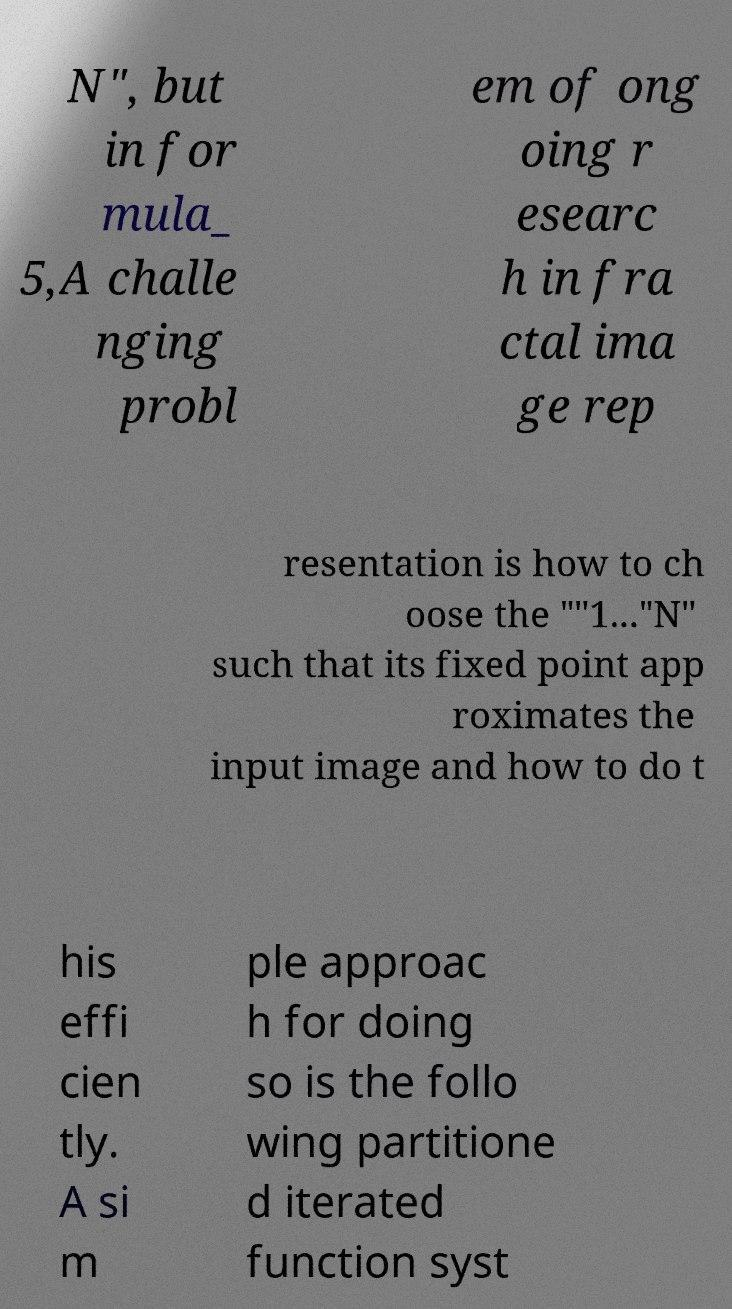There's text embedded in this image that I need extracted. Can you transcribe it verbatim? N", but in for mula_ 5,A challe nging probl em of ong oing r esearc h in fra ctal ima ge rep resentation is how to ch oose the ""1..."N" such that its fixed point app roximates the input image and how to do t his effi cien tly. A si m ple approac h for doing so is the follo wing partitione d iterated function syst 